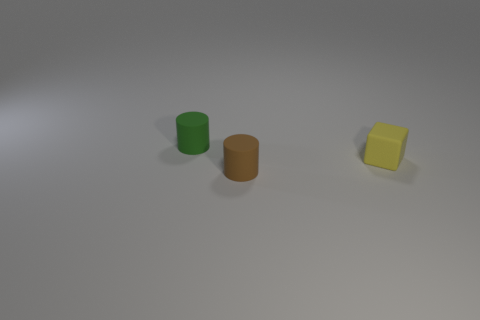Add 1 brown rubber objects. How many objects exist? 4 Subtract all cylinders. How many objects are left? 1 Add 3 large brown rubber spheres. How many large brown rubber spheres exist? 3 Subtract 0 brown blocks. How many objects are left? 3 Subtract all cubes. Subtract all cubes. How many objects are left? 1 Add 1 small cylinders. How many small cylinders are left? 3 